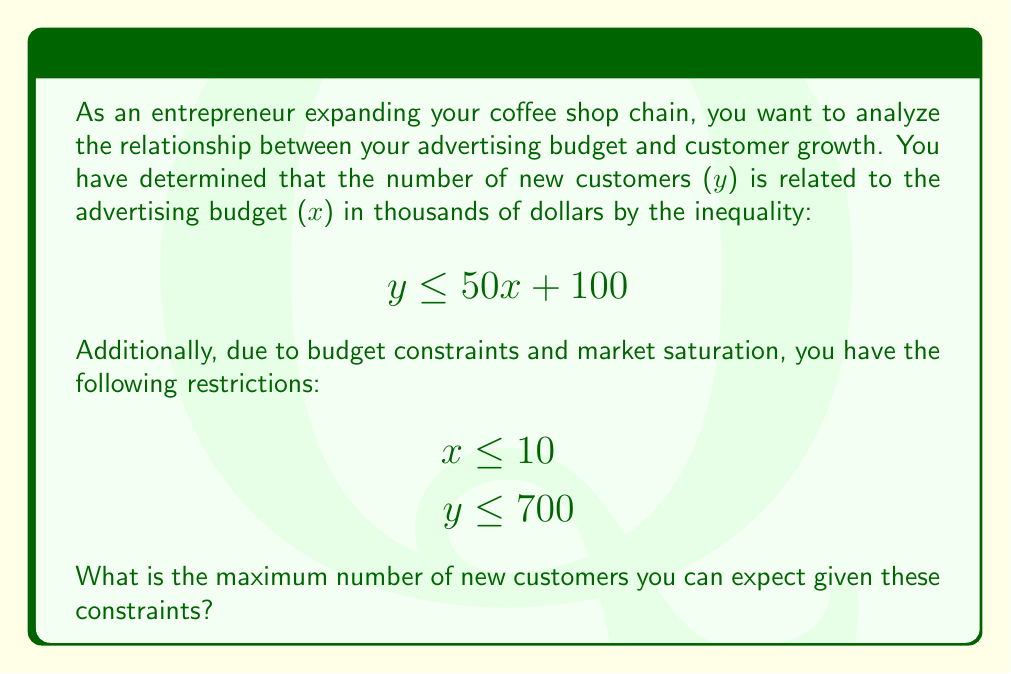Can you solve this math problem? To solve this problem, we need to find the point of intersection between the given inequalities that maximizes y. Let's approach this step-by-step:

1) We have three inequalities:
   $$\begin{align*}
   y &\leq 50x + 100 \quad &(1)\\
   x &\leq 10 \quad &(2)\\
   y &\leq 700 \quad &(3)
   \end{align*}$$

2) The maximum number of customers will occur at one of the intersection points of these inequalities.

3) Let's find the intersection of (1) and (2):
   When $x = 10$, $y = 50(10) + 100 = 600$

4) Now, let's check if this point satisfies inequality (3):
   $600 \leq 700$, so it does.

5) The other potential maximum point is where (1) intersects (3):
   $700 = 50x + 100$
   $600 = 50x$
   $x = 12$

   However, this doesn't satisfy inequality (2), so it's not a valid solution.

6) Therefore, the maximum point that satisfies all constraints is (10, 600).

Thus, the maximum number of new customers you can expect is 600.
Answer: 600 new customers 